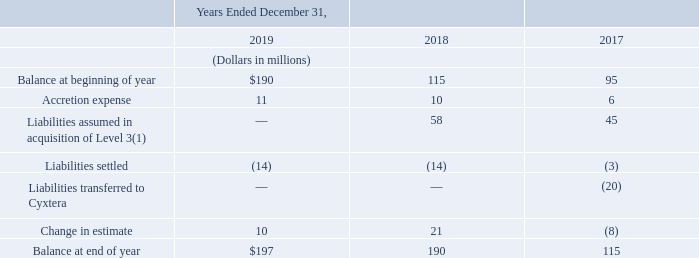Asset Retirement Obligations
At December 31, 2019, our asset retirement obligations balance was primarily related to estimated future costs of removing equipment from leased properties and estimated future costs of properly disposing of asbestos and other hazardous materials upon remodeling or demolishing buildings. Asset retirement obligations are included in other long-term liabilities on our consolidated balance sheets.
As of the Level 3 acquisition date, we recorded liabilities to reflect our fair values of Level 3’s asset retirement obligations. Our fair value estimates were determined using the discounted cash flow method.
The following table provides asset retirement obligation activity:
(1) The liabilities assumed during 2018 relate to purchase price adjustments during the year.
The 2019, 2018 and 2017 change in estimates are offset against gross property, plant and equipment.
What are the 2019, 2018 and 2017 change in estimates offset against? Gross property, plant and equipment. What do the liabilities assumed in acquisition of Level 3 during 2018 relate to? Purchase price adjustments during the year. Which years are considered in the table providing asset retirement obligation activity? 2019, 2018, 2017. Which year has the largest accretion expense? 11>10>7
Answer: 2019. What is the change in balance at end of year in 2019 from 2018?
Answer scale should be: million. 197-190
Answer: 7. What is the average accretion expense across 2017, 2018 and 2019?
Answer scale should be: million. (11+10+6)/3
Answer: 9. 